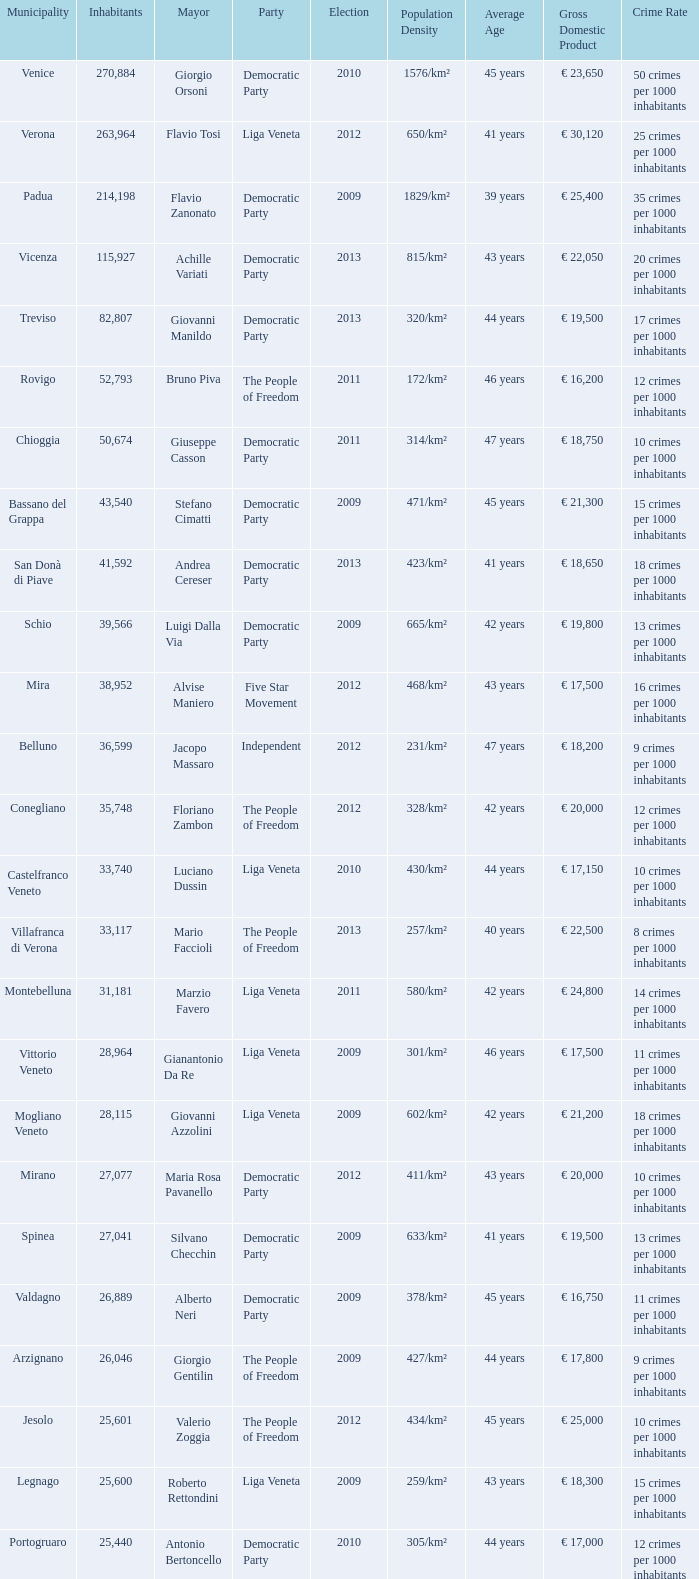How many Inhabitants were in the democratic party for an election before 2009 for Mayor of stefano cimatti? 0.0. 